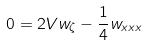<formula> <loc_0><loc_0><loc_500><loc_500>0 = 2 V w _ { \zeta } - \frac { 1 } { 4 } w _ { x x x }</formula> 